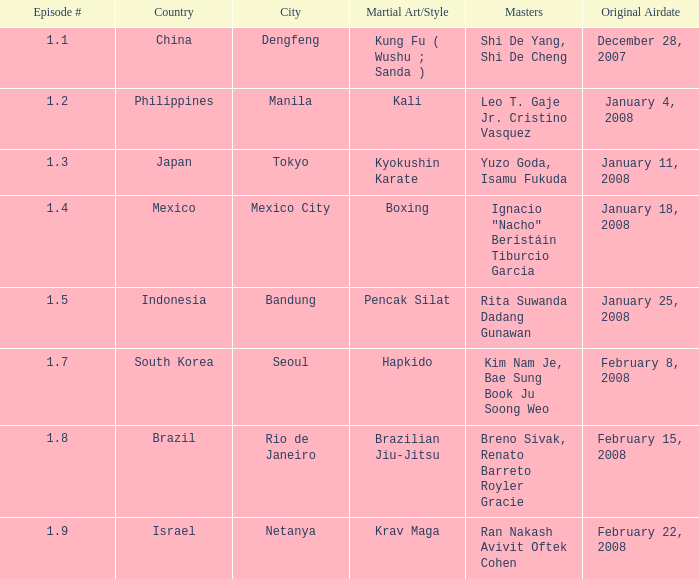Which martial arts style was shown in Rio de Janeiro? Brazilian Jiu-Jitsu. 